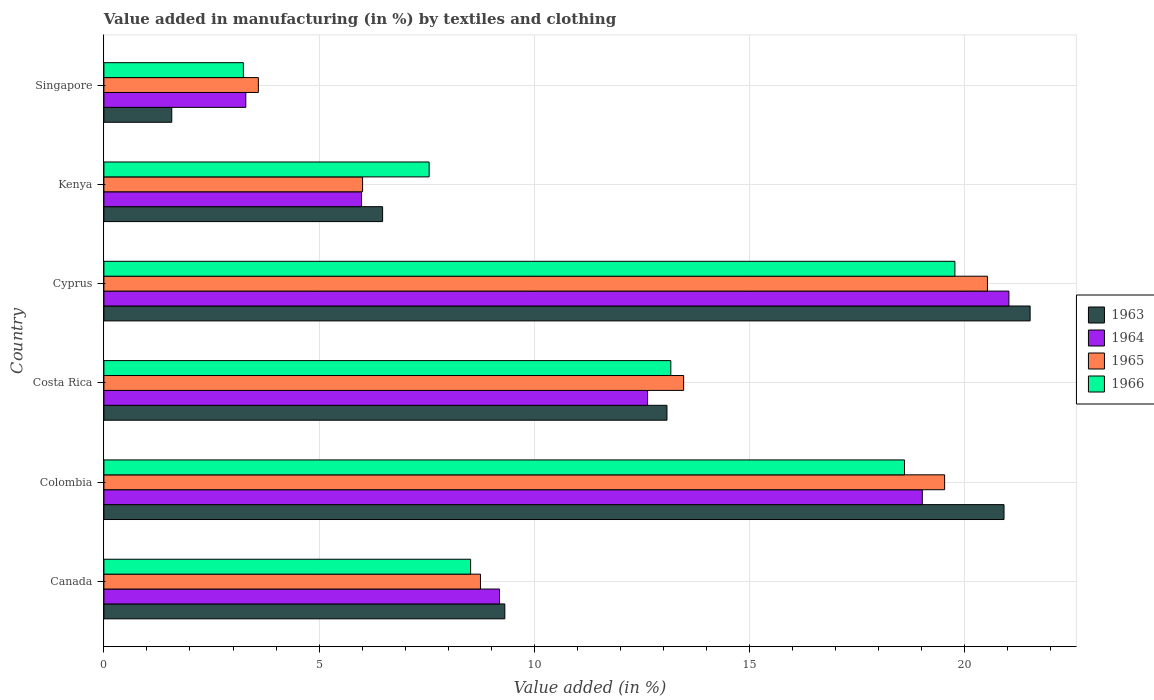How many different coloured bars are there?
Provide a succinct answer. 4. Are the number of bars per tick equal to the number of legend labels?
Your answer should be very brief. Yes. How many bars are there on the 4th tick from the top?
Ensure brevity in your answer.  4. What is the label of the 1st group of bars from the top?
Provide a succinct answer. Singapore. In how many cases, is the number of bars for a given country not equal to the number of legend labels?
Give a very brief answer. 0. What is the percentage of value added in manufacturing by textiles and clothing in 1965 in Canada?
Offer a terse response. 8.75. Across all countries, what is the maximum percentage of value added in manufacturing by textiles and clothing in 1963?
Offer a terse response. 21.52. Across all countries, what is the minimum percentage of value added in manufacturing by textiles and clothing in 1964?
Offer a very short reply. 3.3. In which country was the percentage of value added in manufacturing by textiles and clothing in 1966 maximum?
Ensure brevity in your answer.  Cyprus. In which country was the percentage of value added in manufacturing by textiles and clothing in 1966 minimum?
Give a very brief answer. Singapore. What is the total percentage of value added in manufacturing by textiles and clothing in 1966 in the graph?
Offer a very short reply. 70.87. What is the difference between the percentage of value added in manufacturing by textiles and clothing in 1965 in Cyprus and that in Kenya?
Your answer should be compact. 14.52. What is the difference between the percentage of value added in manufacturing by textiles and clothing in 1965 in Colombia and the percentage of value added in manufacturing by textiles and clothing in 1964 in Singapore?
Provide a short and direct response. 16.24. What is the average percentage of value added in manufacturing by textiles and clothing in 1964 per country?
Ensure brevity in your answer.  11.86. What is the difference between the percentage of value added in manufacturing by textiles and clothing in 1966 and percentage of value added in manufacturing by textiles and clothing in 1965 in Singapore?
Your answer should be very brief. -0.35. In how many countries, is the percentage of value added in manufacturing by textiles and clothing in 1965 greater than 21 %?
Make the answer very short. 0. What is the ratio of the percentage of value added in manufacturing by textiles and clothing in 1963 in Canada to that in Colombia?
Ensure brevity in your answer.  0.45. Is the difference between the percentage of value added in manufacturing by textiles and clothing in 1966 in Canada and Singapore greater than the difference between the percentage of value added in manufacturing by textiles and clothing in 1965 in Canada and Singapore?
Your response must be concise. Yes. What is the difference between the highest and the second highest percentage of value added in manufacturing by textiles and clothing in 1965?
Your response must be concise. 0.99. What is the difference between the highest and the lowest percentage of value added in manufacturing by textiles and clothing in 1965?
Give a very brief answer. 16.94. Is it the case that in every country, the sum of the percentage of value added in manufacturing by textiles and clothing in 1963 and percentage of value added in manufacturing by textiles and clothing in 1964 is greater than the sum of percentage of value added in manufacturing by textiles and clothing in 1966 and percentage of value added in manufacturing by textiles and clothing in 1965?
Keep it short and to the point. No. What does the 1st bar from the top in Kenya represents?
Offer a terse response. 1966. What does the 4th bar from the bottom in Kenya represents?
Offer a terse response. 1966. Is it the case that in every country, the sum of the percentage of value added in manufacturing by textiles and clothing in 1965 and percentage of value added in manufacturing by textiles and clothing in 1963 is greater than the percentage of value added in manufacturing by textiles and clothing in 1966?
Your answer should be very brief. Yes. How many bars are there?
Provide a short and direct response. 24. How many countries are there in the graph?
Keep it short and to the point. 6. Are the values on the major ticks of X-axis written in scientific E-notation?
Your answer should be compact. No. Does the graph contain any zero values?
Provide a succinct answer. No. How many legend labels are there?
Keep it short and to the point. 4. What is the title of the graph?
Make the answer very short. Value added in manufacturing (in %) by textiles and clothing. What is the label or title of the X-axis?
Your response must be concise. Value added (in %). What is the label or title of the Y-axis?
Keep it short and to the point. Country. What is the Value added (in %) in 1963 in Canada?
Offer a very short reply. 9.32. What is the Value added (in %) of 1964 in Canada?
Provide a short and direct response. 9.19. What is the Value added (in %) of 1965 in Canada?
Offer a very short reply. 8.75. What is the Value added (in %) of 1966 in Canada?
Keep it short and to the point. 8.52. What is the Value added (in %) of 1963 in Colombia?
Your answer should be very brief. 20.92. What is the Value added (in %) in 1964 in Colombia?
Your response must be concise. 19.02. What is the Value added (in %) in 1965 in Colombia?
Ensure brevity in your answer.  19.54. What is the Value added (in %) in 1966 in Colombia?
Ensure brevity in your answer.  18.6. What is the Value added (in %) of 1963 in Costa Rica?
Provide a short and direct response. 13.08. What is the Value added (in %) in 1964 in Costa Rica?
Make the answer very short. 12.63. What is the Value added (in %) in 1965 in Costa Rica?
Your answer should be compact. 13.47. What is the Value added (in %) in 1966 in Costa Rica?
Make the answer very short. 13.17. What is the Value added (in %) of 1963 in Cyprus?
Offer a very short reply. 21.52. What is the Value added (in %) in 1964 in Cyprus?
Offer a terse response. 21.03. What is the Value added (in %) in 1965 in Cyprus?
Your answer should be very brief. 20.53. What is the Value added (in %) of 1966 in Cyprus?
Offer a terse response. 19.78. What is the Value added (in %) in 1963 in Kenya?
Offer a very short reply. 6.48. What is the Value added (in %) of 1964 in Kenya?
Make the answer very short. 5.99. What is the Value added (in %) of 1965 in Kenya?
Provide a short and direct response. 6.01. What is the Value added (in %) in 1966 in Kenya?
Keep it short and to the point. 7.56. What is the Value added (in %) in 1963 in Singapore?
Offer a terse response. 1.58. What is the Value added (in %) in 1964 in Singapore?
Make the answer very short. 3.3. What is the Value added (in %) in 1965 in Singapore?
Your answer should be compact. 3.59. What is the Value added (in %) in 1966 in Singapore?
Your response must be concise. 3.24. Across all countries, what is the maximum Value added (in %) in 1963?
Make the answer very short. 21.52. Across all countries, what is the maximum Value added (in %) of 1964?
Your response must be concise. 21.03. Across all countries, what is the maximum Value added (in %) in 1965?
Ensure brevity in your answer.  20.53. Across all countries, what is the maximum Value added (in %) of 1966?
Ensure brevity in your answer.  19.78. Across all countries, what is the minimum Value added (in %) in 1963?
Offer a very short reply. 1.58. Across all countries, what is the minimum Value added (in %) in 1964?
Make the answer very short. 3.3. Across all countries, what is the minimum Value added (in %) in 1965?
Offer a terse response. 3.59. Across all countries, what is the minimum Value added (in %) of 1966?
Offer a very short reply. 3.24. What is the total Value added (in %) of 1963 in the graph?
Give a very brief answer. 72.9. What is the total Value added (in %) in 1964 in the graph?
Your answer should be very brief. 71.16. What is the total Value added (in %) of 1965 in the graph?
Keep it short and to the point. 71.89. What is the total Value added (in %) of 1966 in the graph?
Make the answer very short. 70.87. What is the difference between the Value added (in %) in 1963 in Canada and that in Colombia?
Offer a terse response. -11.6. What is the difference between the Value added (in %) in 1964 in Canada and that in Colombia?
Keep it short and to the point. -9.82. What is the difference between the Value added (in %) of 1965 in Canada and that in Colombia?
Your response must be concise. -10.79. What is the difference between the Value added (in %) in 1966 in Canada and that in Colombia?
Keep it short and to the point. -10.08. What is the difference between the Value added (in %) in 1963 in Canada and that in Costa Rica?
Provide a succinct answer. -3.77. What is the difference between the Value added (in %) in 1964 in Canada and that in Costa Rica?
Your answer should be very brief. -3.44. What is the difference between the Value added (in %) in 1965 in Canada and that in Costa Rica?
Provide a short and direct response. -4.72. What is the difference between the Value added (in %) in 1966 in Canada and that in Costa Rica?
Make the answer very short. -4.65. What is the difference between the Value added (in %) in 1963 in Canada and that in Cyprus?
Your response must be concise. -12.21. What is the difference between the Value added (in %) in 1964 in Canada and that in Cyprus?
Provide a succinct answer. -11.84. What is the difference between the Value added (in %) in 1965 in Canada and that in Cyprus?
Provide a short and direct response. -11.78. What is the difference between the Value added (in %) in 1966 in Canada and that in Cyprus?
Your answer should be compact. -11.25. What is the difference between the Value added (in %) in 1963 in Canada and that in Kenya?
Provide a short and direct response. 2.84. What is the difference between the Value added (in %) of 1964 in Canada and that in Kenya?
Provide a short and direct response. 3.21. What is the difference between the Value added (in %) in 1965 in Canada and that in Kenya?
Your response must be concise. 2.74. What is the difference between the Value added (in %) in 1966 in Canada and that in Kenya?
Provide a succinct answer. 0.96. What is the difference between the Value added (in %) in 1963 in Canada and that in Singapore?
Ensure brevity in your answer.  7.74. What is the difference between the Value added (in %) of 1964 in Canada and that in Singapore?
Ensure brevity in your answer.  5.9. What is the difference between the Value added (in %) of 1965 in Canada and that in Singapore?
Your answer should be compact. 5.16. What is the difference between the Value added (in %) of 1966 in Canada and that in Singapore?
Your response must be concise. 5.28. What is the difference between the Value added (in %) of 1963 in Colombia and that in Costa Rica?
Provide a succinct answer. 7.83. What is the difference between the Value added (in %) in 1964 in Colombia and that in Costa Rica?
Offer a very short reply. 6.38. What is the difference between the Value added (in %) in 1965 in Colombia and that in Costa Rica?
Offer a very short reply. 6.06. What is the difference between the Value added (in %) of 1966 in Colombia and that in Costa Rica?
Offer a terse response. 5.43. What is the difference between the Value added (in %) in 1963 in Colombia and that in Cyprus?
Make the answer very short. -0.61. What is the difference between the Value added (in %) of 1964 in Colombia and that in Cyprus?
Make the answer very short. -2.01. What is the difference between the Value added (in %) in 1965 in Colombia and that in Cyprus?
Give a very brief answer. -0.99. What is the difference between the Value added (in %) in 1966 in Colombia and that in Cyprus?
Provide a short and direct response. -1.17. What is the difference between the Value added (in %) in 1963 in Colombia and that in Kenya?
Offer a terse response. 14.44. What is the difference between the Value added (in %) in 1964 in Colombia and that in Kenya?
Keep it short and to the point. 13.03. What is the difference between the Value added (in %) of 1965 in Colombia and that in Kenya?
Keep it short and to the point. 13.53. What is the difference between the Value added (in %) in 1966 in Colombia and that in Kenya?
Offer a terse response. 11.05. What is the difference between the Value added (in %) in 1963 in Colombia and that in Singapore?
Give a very brief answer. 19.34. What is the difference between the Value added (in %) of 1964 in Colombia and that in Singapore?
Provide a succinct answer. 15.72. What is the difference between the Value added (in %) of 1965 in Colombia and that in Singapore?
Provide a succinct answer. 15.95. What is the difference between the Value added (in %) in 1966 in Colombia and that in Singapore?
Ensure brevity in your answer.  15.36. What is the difference between the Value added (in %) of 1963 in Costa Rica and that in Cyprus?
Your response must be concise. -8.44. What is the difference between the Value added (in %) of 1964 in Costa Rica and that in Cyprus?
Provide a succinct answer. -8.4. What is the difference between the Value added (in %) of 1965 in Costa Rica and that in Cyprus?
Keep it short and to the point. -7.06. What is the difference between the Value added (in %) of 1966 in Costa Rica and that in Cyprus?
Give a very brief answer. -6.6. What is the difference between the Value added (in %) of 1963 in Costa Rica and that in Kenya?
Provide a succinct answer. 6.61. What is the difference between the Value added (in %) in 1964 in Costa Rica and that in Kenya?
Give a very brief answer. 6.65. What is the difference between the Value added (in %) in 1965 in Costa Rica and that in Kenya?
Your answer should be compact. 7.46. What is the difference between the Value added (in %) in 1966 in Costa Rica and that in Kenya?
Provide a short and direct response. 5.62. What is the difference between the Value added (in %) of 1963 in Costa Rica and that in Singapore?
Provide a succinct answer. 11.51. What is the difference between the Value added (in %) of 1964 in Costa Rica and that in Singapore?
Make the answer very short. 9.34. What is the difference between the Value added (in %) in 1965 in Costa Rica and that in Singapore?
Offer a very short reply. 9.88. What is the difference between the Value added (in %) of 1966 in Costa Rica and that in Singapore?
Your answer should be very brief. 9.93. What is the difference between the Value added (in %) in 1963 in Cyprus and that in Kenya?
Give a very brief answer. 15.05. What is the difference between the Value added (in %) of 1964 in Cyprus and that in Kenya?
Ensure brevity in your answer.  15.04. What is the difference between the Value added (in %) in 1965 in Cyprus and that in Kenya?
Your answer should be very brief. 14.52. What is the difference between the Value added (in %) in 1966 in Cyprus and that in Kenya?
Your answer should be compact. 12.22. What is the difference between the Value added (in %) in 1963 in Cyprus and that in Singapore?
Provide a short and direct response. 19.95. What is the difference between the Value added (in %) of 1964 in Cyprus and that in Singapore?
Provide a succinct answer. 17.73. What is the difference between the Value added (in %) in 1965 in Cyprus and that in Singapore?
Offer a terse response. 16.94. What is the difference between the Value added (in %) in 1966 in Cyprus and that in Singapore?
Ensure brevity in your answer.  16.53. What is the difference between the Value added (in %) in 1963 in Kenya and that in Singapore?
Provide a succinct answer. 4.9. What is the difference between the Value added (in %) in 1964 in Kenya and that in Singapore?
Offer a very short reply. 2.69. What is the difference between the Value added (in %) of 1965 in Kenya and that in Singapore?
Your answer should be compact. 2.42. What is the difference between the Value added (in %) of 1966 in Kenya and that in Singapore?
Make the answer very short. 4.32. What is the difference between the Value added (in %) of 1963 in Canada and the Value added (in %) of 1964 in Colombia?
Keep it short and to the point. -9.7. What is the difference between the Value added (in %) in 1963 in Canada and the Value added (in %) in 1965 in Colombia?
Your answer should be very brief. -10.22. What is the difference between the Value added (in %) in 1963 in Canada and the Value added (in %) in 1966 in Colombia?
Provide a succinct answer. -9.29. What is the difference between the Value added (in %) of 1964 in Canada and the Value added (in %) of 1965 in Colombia?
Keep it short and to the point. -10.34. What is the difference between the Value added (in %) in 1964 in Canada and the Value added (in %) in 1966 in Colombia?
Give a very brief answer. -9.41. What is the difference between the Value added (in %) in 1965 in Canada and the Value added (in %) in 1966 in Colombia?
Your answer should be compact. -9.85. What is the difference between the Value added (in %) in 1963 in Canada and the Value added (in %) in 1964 in Costa Rica?
Offer a terse response. -3.32. What is the difference between the Value added (in %) in 1963 in Canada and the Value added (in %) in 1965 in Costa Rica?
Give a very brief answer. -4.16. What is the difference between the Value added (in %) in 1963 in Canada and the Value added (in %) in 1966 in Costa Rica?
Your response must be concise. -3.86. What is the difference between the Value added (in %) of 1964 in Canada and the Value added (in %) of 1965 in Costa Rica?
Your answer should be compact. -4.28. What is the difference between the Value added (in %) in 1964 in Canada and the Value added (in %) in 1966 in Costa Rica?
Your answer should be very brief. -3.98. What is the difference between the Value added (in %) of 1965 in Canada and the Value added (in %) of 1966 in Costa Rica?
Your answer should be very brief. -4.42. What is the difference between the Value added (in %) of 1963 in Canada and the Value added (in %) of 1964 in Cyprus?
Make the answer very short. -11.71. What is the difference between the Value added (in %) in 1963 in Canada and the Value added (in %) in 1965 in Cyprus?
Your answer should be compact. -11.21. What is the difference between the Value added (in %) in 1963 in Canada and the Value added (in %) in 1966 in Cyprus?
Ensure brevity in your answer.  -10.46. What is the difference between the Value added (in %) in 1964 in Canada and the Value added (in %) in 1965 in Cyprus?
Give a very brief answer. -11.34. What is the difference between the Value added (in %) of 1964 in Canada and the Value added (in %) of 1966 in Cyprus?
Make the answer very short. -10.58. What is the difference between the Value added (in %) in 1965 in Canada and the Value added (in %) in 1966 in Cyprus?
Provide a succinct answer. -11.02. What is the difference between the Value added (in %) of 1963 in Canada and the Value added (in %) of 1964 in Kenya?
Make the answer very short. 3.33. What is the difference between the Value added (in %) in 1963 in Canada and the Value added (in %) in 1965 in Kenya?
Ensure brevity in your answer.  3.31. What is the difference between the Value added (in %) in 1963 in Canada and the Value added (in %) in 1966 in Kenya?
Provide a short and direct response. 1.76. What is the difference between the Value added (in %) of 1964 in Canada and the Value added (in %) of 1965 in Kenya?
Make the answer very short. 3.18. What is the difference between the Value added (in %) of 1964 in Canada and the Value added (in %) of 1966 in Kenya?
Your answer should be compact. 1.64. What is the difference between the Value added (in %) of 1965 in Canada and the Value added (in %) of 1966 in Kenya?
Your answer should be compact. 1.19. What is the difference between the Value added (in %) of 1963 in Canada and the Value added (in %) of 1964 in Singapore?
Your response must be concise. 6.02. What is the difference between the Value added (in %) in 1963 in Canada and the Value added (in %) in 1965 in Singapore?
Provide a succinct answer. 5.73. What is the difference between the Value added (in %) in 1963 in Canada and the Value added (in %) in 1966 in Singapore?
Offer a terse response. 6.08. What is the difference between the Value added (in %) of 1964 in Canada and the Value added (in %) of 1965 in Singapore?
Give a very brief answer. 5.6. What is the difference between the Value added (in %) in 1964 in Canada and the Value added (in %) in 1966 in Singapore?
Provide a short and direct response. 5.95. What is the difference between the Value added (in %) in 1965 in Canada and the Value added (in %) in 1966 in Singapore?
Ensure brevity in your answer.  5.51. What is the difference between the Value added (in %) in 1963 in Colombia and the Value added (in %) in 1964 in Costa Rica?
Provide a short and direct response. 8.28. What is the difference between the Value added (in %) in 1963 in Colombia and the Value added (in %) in 1965 in Costa Rica?
Offer a terse response. 7.44. What is the difference between the Value added (in %) in 1963 in Colombia and the Value added (in %) in 1966 in Costa Rica?
Keep it short and to the point. 7.74. What is the difference between the Value added (in %) of 1964 in Colombia and the Value added (in %) of 1965 in Costa Rica?
Your answer should be very brief. 5.55. What is the difference between the Value added (in %) of 1964 in Colombia and the Value added (in %) of 1966 in Costa Rica?
Offer a terse response. 5.84. What is the difference between the Value added (in %) in 1965 in Colombia and the Value added (in %) in 1966 in Costa Rica?
Your response must be concise. 6.36. What is the difference between the Value added (in %) in 1963 in Colombia and the Value added (in %) in 1964 in Cyprus?
Make the answer very short. -0.11. What is the difference between the Value added (in %) of 1963 in Colombia and the Value added (in %) of 1965 in Cyprus?
Keep it short and to the point. 0.39. What is the difference between the Value added (in %) in 1963 in Colombia and the Value added (in %) in 1966 in Cyprus?
Offer a terse response. 1.14. What is the difference between the Value added (in %) in 1964 in Colombia and the Value added (in %) in 1965 in Cyprus?
Give a very brief answer. -1.51. What is the difference between the Value added (in %) in 1964 in Colombia and the Value added (in %) in 1966 in Cyprus?
Offer a very short reply. -0.76. What is the difference between the Value added (in %) in 1965 in Colombia and the Value added (in %) in 1966 in Cyprus?
Ensure brevity in your answer.  -0.24. What is the difference between the Value added (in %) of 1963 in Colombia and the Value added (in %) of 1964 in Kenya?
Offer a terse response. 14.93. What is the difference between the Value added (in %) of 1963 in Colombia and the Value added (in %) of 1965 in Kenya?
Offer a very short reply. 14.91. What is the difference between the Value added (in %) of 1963 in Colombia and the Value added (in %) of 1966 in Kenya?
Provide a short and direct response. 13.36. What is the difference between the Value added (in %) in 1964 in Colombia and the Value added (in %) in 1965 in Kenya?
Ensure brevity in your answer.  13.01. What is the difference between the Value added (in %) of 1964 in Colombia and the Value added (in %) of 1966 in Kenya?
Offer a very short reply. 11.46. What is the difference between the Value added (in %) in 1965 in Colombia and the Value added (in %) in 1966 in Kenya?
Make the answer very short. 11.98. What is the difference between the Value added (in %) in 1963 in Colombia and the Value added (in %) in 1964 in Singapore?
Your answer should be compact. 17.62. What is the difference between the Value added (in %) of 1963 in Colombia and the Value added (in %) of 1965 in Singapore?
Offer a terse response. 17.33. What is the difference between the Value added (in %) in 1963 in Colombia and the Value added (in %) in 1966 in Singapore?
Your answer should be very brief. 17.68. What is the difference between the Value added (in %) in 1964 in Colombia and the Value added (in %) in 1965 in Singapore?
Your answer should be very brief. 15.43. What is the difference between the Value added (in %) of 1964 in Colombia and the Value added (in %) of 1966 in Singapore?
Your response must be concise. 15.78. What is the difference between the Value added (in %) in 1965 in Colombia and the Value added (in %) in 1966 in Singapore?
Your response must be concise. 16.3. What is the difference between the Value added (in %) of 1963 in Costa Rica and the Value added (in %) of 1964 in Cyprus?
Provide a short and direct response. -7.95. What is the difference between the Value added (in %) in 1963 in Costa Rica and the Value added (in %) in 1965 in Cyprus?
Offer a very short reply. -7.45. What is the difference between the Value added (in %) in 1963 in Costa Rica and the Value added (in %) in 1966 in Cyprus?
Provide a short and direct response. -6.69. What is the difference between the Value added (in %) of 1964 in Costa Rica and the Value added (in %) of 1965 in Cyprus?
Offer a very short reply. -7.9. What is the difference between the Value added (in %) of 1964 in Costa Rica and the Value added (in %) of 1966 in Cyprus?
Offer a very short reply. -7.14. What is the difference between the Value added (in %) of 1965 in Costa Rica and the Value added (in %) of 1966 in Cyprus?
Offer a terse response. -6.3. What is the difference between the Value added (in %) in 1963 in Costa Rica and the Value added (in %) in 1964 in Kenya?
Offer a terse response. 7.1. What is the difference between the Value added (in %) of 1963 in Costa Rica and the Value added (in %) of 1965 in Kenya?
Your response must be concise. 7.07. What is the difference between the Value added (in %) in 1963 in Costa Rica and the Value added (in %) in 1966 in Kenya?
Make the answer very short. 5.53. What is the difference between the Value added (in %) of 1964 in Costa Rica and the Value added (in %) of 1965 in Kenya?
Offer a very short reply. 6.62. What is the difference between the Value added (in %) of 1964 in Costa Rica and the Value added (in %) of 1966 in Kenya?
Offer a terse response. 5.08. What is the difference between the Value added (in %) in 1965 in Costa Rica and the Value added (in %) in 1966 in Kenya?
Give a very brief answer. 5.91. What is the difference between the Value added (in %) of 1963 in Costa Rica and the Value added (in %) of 1964 in Singapore?
Offer a terse response. 9.79. What is the difference between the Value added (in %) of 1963 in Costa Rica and the Value added (in %) of 1965 in Singapore?
Offer a terse response. 9.5. What is the difference between the Value added (in %) in 1963 in Costa Rica and the Value added (in %) in 1966 in Singapore?
Provide a short and direct response. 9.84. What is the difference between the Value added (in %) in 1964 in Costa Rica and the Value added (in %) in 1965 in Singapore?
Offer a terse response. 9.04. What is the difference between the Value added (in %) of 1964 in Costa Rica and the Value added (in %) of 1966 in Singapore?
Keep it short and to the point. 9.39. What is the difference between the Value added (in %) in 1965 in Costa Rica and the Value added (in %) in 1966 in Singapore?
Your answer should be compact. 10.23. What is the difference between the Value added (in %) of 1963 in Cyprus and the Value added (in %) of 1964 in Kenya?
Provide a succinct answer. 15.54. What is the difference between the Value added (in %) in 1963 in Cyprus and the Value added (in %) in 1965 in Kenya?
Your response must be concise. 15.51. What is the difference between the Value added (in %) in 1963 in Cyprus and the Value added (in %) in 1966 in Kenya?
Give a very brief answer. 13.97. What is the difference between the Value added (in %) of 1964 in Cyprus and the Value added (in %) of 1965 in Kenya?
Ensure brevity in your answer.  15.02. What is the difference between the Value added (in %) in 1964 in Cyprus and the Value added (in %) in 1966 in Kenya?
Give a very brief answer. 13.47. What is the difference between the Value added (in %) of 1965 in Cyprus and the Value added (in %) of 1966 in Kenya?
Offer a terse response. 12.97. What is the difference between the Value added (in %) in 1963 in Cyprus and the Value added (in %) in 1964 in Singapore?
Your answer should be compact. 18.23. What is the difference between the Value added (in %) of 1963 in Cyprus and the Value added (in %) of 1965 in Singapore?
Offer a terse response. 17.93. What is the difference between the Value added (in %) of 1963 in Cyprus and the Value added (in %) of 1966 in Singapore?
Offer a very short reply. 18.28. What is the difference between the Value added (in %) of 1964 in Cyprus and the Value added (in %) of 1965 in Singapore?
Keep it short and to the point. 17.44. What is the difference between the Value added (in %) of 1964 in Cyprus and the Value added (in %) of 1966 in Singapore?
Your answer should be compact. 17.79. What is the difference between the Value added (in %) in 1965 in Cyprus and the Value added (in %) in 1966 in Singapore?
Offer a very short reply. 17.29. What is the difference between the Value added (in %) of 1963 in Kenya and the Value added (in %) of 1964 in Singapore?
Provide a short and direct response. 3.18. What is the difference between the Value added (in %) of 1963 in Kenya and the Value added (in %) of 1965 in Singapore?
Your answer should be compact. 2.89. What is the difference between the Value added (in %) of 1963 in Kenya and the Value added (in %) of 1966 in Singapore?
Provide a succinct answer. 3.24. What is the difference between the Value added (in %) in 1964 in Kenya and the Value added (in %) in 1965 in Singapore?
Ensure brevity in your answer.  2.4. What is the difference between the Value added (in %) of 1964 in Kenya and the Value added (in %) of 1966 in Singapore?
Provide a succinct answer. 2.75. What is the difference between the Value added (in %) of 1965 in Kenya and the Value added (in %) of 1966 in Singapore?
Your answer should be compact. 2.77. What is the average Value added (in %) of 1963 per country?
Your answer should be very brief. 12.15. What is the average Value added (in %) in 1964 per country?
Your answer should be compact. 11.86. What is the average Value added (in %) in 1965 per country?
Ensure brevity in your answer.  11.98. What is the average Value added (in %) of 1966 per country?
Offer a very short reply. 11.81. What is the difference between the Value added (in %) in 1963 and Value added (in %) in 1964 in Canada?
Your answer should be very brief. 0.12. What is the difference between the Value added (in %) in 1963 and Value added (in %) in 1965 in Canada?
Give a very brief answer. 0.57. What is the difference between the Value added (in %) in 1963 and Value added (in %) in 1966 in Canada?
Ensure brevity in your answer.  0.8. What is the difference between the Value added (in %) of 1964 and Value added (in %) of 1965 in Canada?
Make the answer very short. 0.44. What is the difference between the Value added (in %) in 1964 and Value added (in %) in 1966 in Canada?
Provide a short and direct response. 0.67. What is the difference between the Value added (in %) in 1965 and Value added (in %) in 1966 in Canada?
Make the answer very short. 0.23. What is the difference between the Value added (in %) in 1963 and Value added (in %) in 1964 in Colombia?
Ensure brevity in your answer.  1.9. What is the difference between the Value added (in %) in 1963 and Value added (in %) in 1965 in Colombia?
Make the answer very short. 1.38. What is the difference between the Value added (in %) in 1963 and Value added (in %) in 1966 in Colombia?
Your answer should be very brief. 2.31. What is the difference between the Value added (in %) in 1964 and Value added (in %) in 1965 in Colombia?
Your answer should be compact. -0.52. What is the difference between the Value added (in %) of 1964 and Value added (in %) of 1966 in Colombia?
Offer a very short reply. 0.41. What is the difference between the Value added (in %) in 1965 and Value added (in %) in 1966 in Colombia?
Ensure brevity in your answer.  0.93. What is the difference between the Value added (in %) of 1963 and Value added (in %) of 1964 in Costa Rica?
Provide a succinct answer. 0.45. What is the difference between the Value added (in %) of 1963 and Value added (in %) of 1965 in Costa Rica?
Ensure brevity in your answer.  -0.39. What is the difference between the Value added (in %) in 1963 and Value added (in %) in 1966 in Costa Rica?
Give a very brief answer. -0.09. What is the difference between the Value added (in %) of 1964 and Value added (in %) of 1965 in Costa Rica?
Give a very brief answer. -0.84. What is the difference between the Value added (in %) of 1964 and Value added (in %) of 1966 in Costa Rica?
Offer a terse response. -0.54. What is the difference between the Value added (in %) in 1965 and Value added (in %) in 1966 in Costa Rica?
Offer a terse response. 0.3. What is the difference between the Value added (in %) of 1963 and Value added (in %) of 1964 in Cyprus?
Your answer should be very brief. 0.49. What is the difference between the Value added (in %) of 1963 and Value added (in %) of 1966 in Cyprus?
Keep it short and to the point. 1.75. What is the difference between the Value added (in %) of 1964 and Value added (in %) of 1965 in Cyprus?
Give a very brief answer. 0.5. What is the difference between the Value added (in %) of 1964 and Value added (in %) of 1966 in Cyprus?
Offer a terse response. 1.25. What is the difference between the Value added (in %) of 1965 and Value added (in %) of 1966 in Cyprus?
Give a very brief answer. 0.76. What is the difference between the Value added (in %) in 1963 and Value added (in %) in 1964 in Kenya?
Give a very brief answer. 0.49. What is the difference between the Value added (in %) in 1963 and Value added (in %) in 1965 in Kenya?
Provide a succinct answer. 0.47. What is the difference between the Value added (in %) of 1963 and Value added (in %) of 1966 in Kenya?
Provide a short and direct response. -1.08. What is the difference between the Value added (in %) in 1964 and Value added (in %) in 1965 in Kenya?
Keep it short and to the point. -0.02. What is the difference between the Value added (in %) in 1964 and Value added (in %) in 1966 in Kenya?
Offer a terse response. -1.57. What is the difference between the Value added (in %) in 1965 and Value added (in %) in 1966 in Kenya?
Your answer should be very brief. -1.55. What is the difference between the Value added (in %) in 1963 and Value added (in %) in 1964 in Singapore?
Keep it short and to the point. -1.72. What is the difference between the Value added (in %) in 1963 and Value added (in %) in 1965 in Singapore?
Provide a succinct answer. -2.01. What is the difference between the Value added (in %) of 1963 and Value added (in %) of 1966 in Singapore?
Your response must be concise. -1.66. What is the difference between the Value added (in %) of 1964 and Value added (in %) of 1965 in Singapore?
Make the answer very short. -0.29. What is the difference between the Value added (in %) in 1964 and Value added (in %) in 1966 in Singapore?
Your response must be concise. 0.06. What is the difference between the Value added (in %) in 1965 and Value added (in %) in 1966 in Singapore?
Your answer should be compact. 0.35. What is the ratio of the Value added (in %) of 1963 in Canada to that in Colombia?
Your answer should be very brief. 0.45. What is the ratio of the Value added (in %) in 1964 in Canada to that in Colombia?
Ensure brevity in your answer.  0.48. What is the ratio of the Value added (in %) in 1965 in Canada to that in Colombia?
Offer a very short reply. 0.45. What is the ratio of the Value added (in %) of 1966 in Canada to that in Colombia?
Make the answer very short. 0.46. What is the ratio of the Value added (in %) of 1963 in Canada to that in Costa Rica?
Give a very brief answer. 0.71. What is the ratio of the Value added (in %) in 1964 in Canada to that in Costa Rica?
Offer a terse response. 0.73. What is the ratio of the Value added (in %) in 1965 in Canada to that in Costa Rica?
Provide a succinct answer. 0.65. What is the ratio of the Value added (in %) of 1966 in Canada to that in Costa Rica?
Give a very brief answer. 0.65. What is the ratio of the Value added (in %) in 1963 in Canada to that in Cyprus?
Offer a very short reply. 0.43. What is the ratio of the Value added (in %) in 1964 in Canada to that in Cyprus?
Make the answer very short. 0.44. What is the ratio of the Value added (in %) in 1965 in Canada to that in Cyprus?
Your answer should be very brief. 0.43. What is the ratio of the Value added (in %) in 1966 in Canada to that in Cyprus?
Your response must be concise. 0.43. What is the ratio of the Value added (in %) of 1963 in Canada to that in Kenya?
Keep it short and to the point. 1.44. What is the ratio of the Value added (in %) in 1964 in Canada to that in Kenya?
Your answer should be compact. 1.54. What is the ratio of the Value added (in %) in 1965 in Canada to that in Kenya?
Make the answer very short. 1.46. What is the ratio of the Value added (in %) in 1966 in Canada to that in Kenya?
Provide a succinct answer. 1.13. What is the ratio of the Value added (in %) of 1963 in Canada to that in Singapore?
Offer a very short reply. 5.91. What is the ratio of the Value added (in %) of 1964 in Canada to that in Singapore?
Offer a very short reply. 2.79. What is the ratio of the Value added (in %) in 1965 in Canada to that in Singapore?
Offer a terse response. 2.44. What is the ratio of the Value added (in %) of 1966 in Canada to that in Singapore?
Make the answer very short. 2.63. What is the ratio of the Value added (in %) of 1963 in Colombia to that in Costa Rica?
Keep it short and to the point. 1.6. What is the ratio of the Value added (in %) of 1964 in Colombia to that in Costa Rica?
Provide a short and direct response. 1.51. What is the ratio of the Value added (in %) of 1965 in Colombia to that in Costa Rica?
Keep it short and to the point. 1.45. What is the ratio of the Value added (in %) of 1966 in Colombia to that in Costa Rica?
Offer a very short reply. 1.41. What is the ratio of the Value added (in %) of 1963 in Colombia to that in Cyprus?
Your answer should be very brief. 0.97. What is the ratio of the Value added (in %) in 1964 in Colombia to that in Cyprus?
Give a very brief answer. 0.9. What is the ratio of the Value added (in %) of 1965 in Colombia to that in Cyprus?
Keep it short and to the point. 0.95. What is the ratio of the Value added (in %) in 1966 in Colombia to that in Cyprus?
Offer a terse response. 0.94. What is the ratio of the Value added (in %) in 1963 in Colombia to that in Kenya?
Provide a succinct answer. 3.23. What is the ratio of the Value added (in %) of 1964 in Colombia to that in Kenya?
Offer a very short reply. 3.18. What is the ratio of the Value added (in %) in 1965 in Colombia to that in Kenya?
Ensure brevity in your answer.  3.25. What is the ratio of the Value added (in %) in 1966 in Colombia to that in Kenya?
Your response must be concise. 2.46. What is the ratio of the Value added (in %) of 1963 in Colombia to that in Singapore?
Provide a succinct answer. 13.26. What is the ratio of the Value added (in %) in 1964 in Colombia to that in Singapore?
Your answer should be compact. 5.77. What is the ratio of the Value added (in %) in 1965 in Colombia to that in Singapore?
Your answer should be very brief. 5.44. What is the ratio of the Value added (in %) of 1966 in Colombia to that in Singapore?
Ensure brevity in your answer.  5.74. What is the ratio of the Value added (in %) in 1963 in Costa Rica to that in Cyprus?
Your answer should be compact. 0.61. What is the ratio of the Value added (in %) of 1964 in Costa Rica to that in Cyprus?
Ensure brevity in your answer.  0.6. What is the ratio of the Value added (in %) of 1965 in Costa Rica to that in Cyprus?
Your answer should be compact. 0.66. What is the ratio of the Value added (in %) in 1966 in Costa Rica to that in Cyprus?
Provide a short and direct response. 0.67. What is the ratio of the Value added (in %) in 1963 in Costa Rica to that in Kenya?
Offer a terse response. 2.02. What is the ratio of the Value added (in %) in 1964 in Costa Rica to that in Kenya?
Offer a very short reply. 2.11. What is the ratio of the Value added (in %) in 1965 in Costa Rica to that in Kenya?
Your response must be concise. 2.24. What is the ratio of the Value added (in %) in 1966 in Costa Rica to that in Kenya?
Make the answer very short. 1.74. What is the ratio of the Value added (in %) in 1963 in Costa Rica to that in Singapore?
Provide a short and direct response. 8.3. What is the ratio of the Value added (in %) in 1964 in Costa Rica to that in Singapore?
Provide a short and direct response. 3.83. What is the ratio of the Value added (in %) in 1965 in Costa Rica to that in Singapore?
Keep it short and to the point. 3.75. What is the ratio of the Value added (in %) in 1966 in Costa Rica to that in Singapore?
Provide a succinct answer. 4.06. What is the ratio of the Value added (in %) of 1963 in Cyprus to that in Kenya?
Offer a very short reply. 3.32. What is the ratio of the Value added (in %) in 1964 in Cyprus to that in Kenya?
Offer a very short reply. 3.51. What is the ratio of the Value added (in %) of 1965 in Cyprus to that in Kenya?
Your response must be concise. 3.42. What is the ratio of the Value added (in %) in 1966 in Cyprus to that in Kenya?
Your response must be concise. 2.62. What is the ratio of the Value added (in %) of 1963 in Cyprus to that in Singapore?
Your response must be concise. 13.65. What is the ratio of the Value added (in %) of 1964 in Cyprus to that in Singapore?
Provide a short and direct response. 6.38. What is the ratio of the Value added (in %) in 1965 in Cyprus to that in Singapore?
Your answer should be very brief. 5.72. What is the ratio of the Value added (in %) in 1966 in Cyprus to that in Singapore?
Keep it short and to the point. 6.1. What is the ratio of the Value added (in %) of 1963 in Kenya to that in Singapore?
Provide a succinct answer. 4.11. What is the ratio of the Value added (in %) of 1964 in Kenya to that in Singapore?
Offer a very short reply. 1.82. What is the ratio of the Value added (in %) of 1965 in Kenya to that in Singapore?
Your answer should be very brief. 1.67. What is the ratio of the Value added (in %) of 1966 in Kenya to that in Singapore?
Your answer should be very brief. 2.33. What is the difference between the highest and the second highest Value added (in %) in 1963?
Make the answer very short. 0.61. What is the difference between the highest and the second highest Value added (in %) in 1964?
Your answer should be compact. 2.01. What is the difference between the highest and the second highest Value added (in %) in 1966?
Make the answer very short. 1.17. What is the difference between the highest and the lowest Value added (in %) in 1963?
Offer a very short reply. 19.95. What is the difference between the highest and the lowest Value added (in %) of 1964?
Offer a terse response. 17.73. What is the difference between the highest and the lowest Value added (in %) in 1965?
Your answer should be compact. 16.94. What is the difference between the highest and the lowest Value added (in %) in 1966?
Your answer should be very brief. 16.53. 